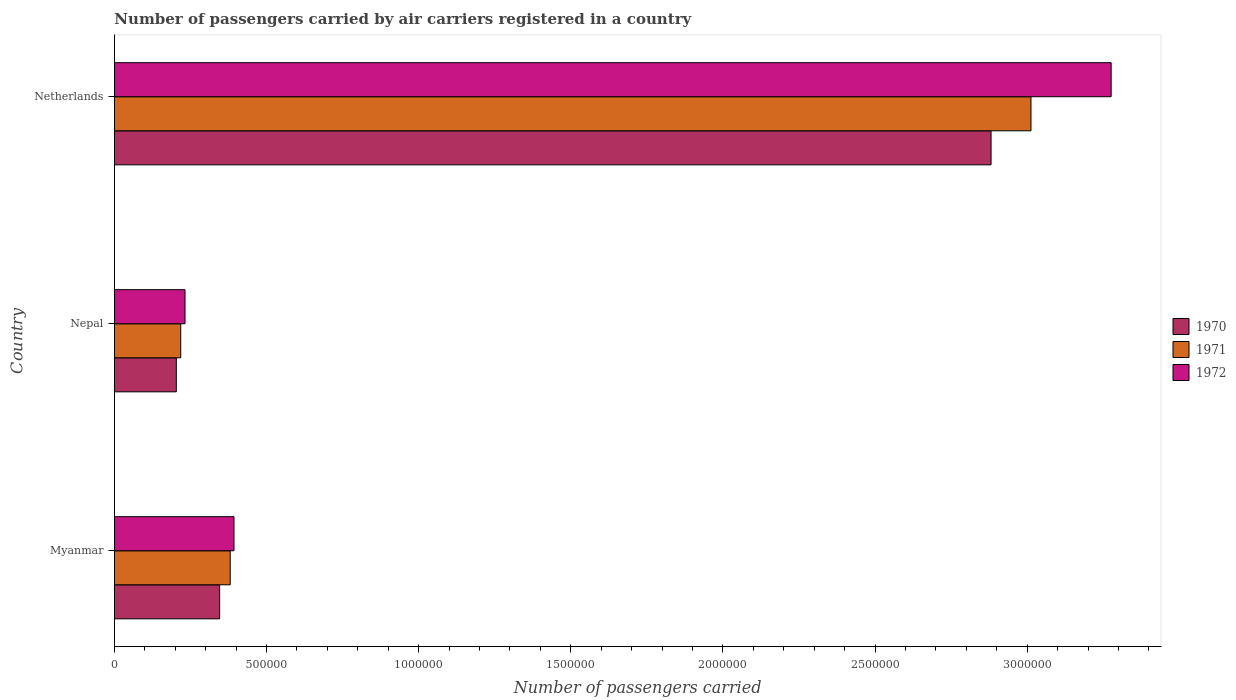How many different coloured bars are there?
Offer a very short reply. 3. How many groups of bars are there?
Your answer should be compact. 3. Are the number of bars per tick equal to the number of legend labels?
Provide a succinct answer. Yes. What is the label of the 2nd group of bars from the top?
Ensure brevity in your answer.  Nepal. In how many cases, is the number of bars for a given country not equal to the number of legend labels?
Offer a very short reply. 0. What is the number of passengers carried by air carriers in 1972 in Nepal?
Your response must be concise. 2.32e+05. Across all countries, what is the maximum number of passengers carried by air carriers in 1972?
Your response must be concise. 3.28e+06. Across all countries, what is the minimum number of passengers carried by air carriers in 1972?
Your answer should be very brief. 2.32e+05. In which country was the number of passengers carried by air carriers in 1972 minimum?
Offer a terse response. Nepal. What is the total number of passengers carried by air carriers in 1970 in the graph?
Make the answer very short. 3.43e+06. What is the difference between the number of passengers carried by air carriers in 1971 in Myanmar and that in Netherlands?
Provide a short and direct response. -2.63e+06. What is the difference between the number of passengers carried by air carriers in 1972 in Netherlands and the number of passengers carried by air carriers in 1970 in Nepal?
Your answer should be compact. 3.07e+06. What is the average number of passengers carried by air carriers in 1972 per country?
Your answer should be very brief. 1.30e+06. What is the difference between the number of passengers carried by air carriers in 1972 and number of passengers carried by air carriers in 1970 in Nepal?
Provide a succinct answer. 2.86e+04. What is the ratio of the number of passengers carried by air carriers in 1970 in Myanmar to that in Nepal?
Ensure brevity in your answer.  1.7. What is the difference between the highest and the second highest number of passengers carried by air carriers in 1972?
Provide a succinct answer. 2.88e+06. What is the difference between the highest and the lowest number of passengers carried by air carriers in 1970?
Provide a short and direct response. 2.68e+06. In how many countries, is the number of passengers carried by air carriers in 1972 greater than the average number of passengers carried by air carriers in 1972 taken over all countries?
Ensure brevity in your answer.  1. What does the 2nd bar from the top in Myanmar represents?
Give a very brief answer. 1971. What does the 3rd bar from the bottom in Myanmar represents?
Offer a terse response. 1972. Is it the case that in every country, the sum of the number of passengers carried by air carriers in 1971 and number of passengers carried by air carriers in 1970 is greater than the number of passengers carried by air carriers in 1972?
Offer a very short reply. Yes. How many countries are there in the graph?
Ensure brevity in your answer.  3. What is the difference between two consecutive major ticks on the X-axis?
Provide a short and direct response. 5.00e+05. Are the values on the major ticks of X-axis written in scientific E-notation?
Give a very brief answer. No. Does the graph contain grids?
Provide a short and direct response. No. How many legend labels are there?
Your answer should be compact. 3. What is the title of the graph?
Offer a very short reply. Number of passengers carried by air carriers registered in a country. What is the label or title of the X-axis?
Provide a short and direct response. Number of passengers carried. What is the label or title of the Y-axis?
Provide a succinct answer. Country. What is the Number of passengers carried of 1970 in Myanmar?
Provide a succinct answer. 3.46e+05. What is the Number of passengers carried of 1971 in Myanmar?
Your response must be concise. 3.80e+05. What is the Number of passengers carried in 1972 in Myanmar?
Offer a terse response. 3.93e+05. What is the Number of passengers carried in 1970 in Nepal?
Ensure brevity in your answer.  2.03e+05. What is the Number of passengers carried in 1971 in Nepal?
Give a very brief answer. 2.18e+05. What is the Number of passengers carried in 1972 in Nepal?
Provide a short and direct response. 2.32e+05. What is the Number of passengers carried of 1970 in Netherlands?
Give a very brief answer. 2.88e+06. What is the Number of passengers carried in 1971 in Netherlands?
Your answer should be compact. 3.01e+06. What is the Number of passengers carried in 1972 in Netherlands?
Offer a terse response. 3.28e+06. Across all countries, what is the maximum Number of passengers carried in 1970?
Your response must be concise. 2.88e+06. Across all countries, what is the maximum Number of passengers carried in 1971?
Give a very brief answer. 3.01e+06. Across all countries, what is the maximum Number of passengers carried of 1972?
Your answer should be very brief. 3.28e+06. Across all countries, what is the minimum Number of passengers carried in 1970?
Make the answer very short. 2.03e+05. Across all countries, what is the minimum Number of passengers carried of 1971?
Offer a terse response. 2.18e+05. Across all countries, what is the minimum Number of passengers carried in 1972?
Make the answer very short. 2.32e+05. What is the total Number of passengers carried of 1970 in the graph?
Provide a succinct answer. 3.43e+06. What is the total Number of passengers carried in 1971 in the graph?
Offer a very short reply. 3.61e+06. What is the total Number of passengers carried in 1972 in the graph?
Make the answer very short. 3.90e+06. What is the difference between the Number of passengers carried of 1970 in Myanmar and that in Nepal?
Provide a short and direct response. 1.42e+05. What is the difference between the Number of passengers carried of 1971 in Myanmar and that in Nepal?
Provide a short and direct response. 1.63e+05. What is the difference between the Number of passengers carried in 1972 in Myanmar and that in Nepal?
Provide a succinct answer. 1.61e+05. What is the difference between the Number of passengers carried of 1970 in Myanmar and that in Netherlands?
Make the answer very short. -2.54e+06. What is the difference between the Number of passengers carried of 1971 in Myanmar and that in Netherlands?
Your answer should be compact. -2.63e+06. What is the difference between the Number of passengers carried in 1972 in Myanmar and that in Netherlands?
Provide a succinct answer. -2.88e+06. What is the difference between the Number of passengers carried of 1970 in Nepal and that in Netherlands?
Make the answer very short. -2.68e+06. What is the difference between the Number of passengers carried in 1971 in Nepal and that in Netherlands?
Give a very brief answer. -2.79e+06. What is the difference between the Number of passengers carried in 1972 in Nepal and that in Netherlands?
Ensure brevity in your answer.  -3.04e+06. What is the difference between the Number of passengers carried in 1970 in Myanmar and the Number of passengers carried in 1971 in Nepal?
Your answer should be very brief. 1.28e+05. What is the difference between the Number of passengers carried in 1970 in Myanmar and the Number of passengers carried in 1972 in Nepal?
Your answer should be compact. 1.14e+05. What is the difference between the Number of passengers carried in 1971 in Myanmar and the Number of passengers carried in 1972 in Nepal?
Your response must be concise. 1.48e+05. What is the difference between the Number of passengers carried in 1970 in Myanmar and the Number of passengers carried in 1971 in Netherlands?
Give a very brief answer. -2.67e+06. What is the difference between the Number of passengers carried in 1970 in Myanmar and the Number of passengers carried in 1972 in Netherlands?
Offer a very short reply. -2.93e+06. What is the difference between the Number of passengers carried in 1971 in Myanmar and the Number of passengers carried in 1972 in Netherlands?
Give a very brief answer. -2.90e+06. What is the difference between the Number of passengers carried in 1970 in Nepal and the Number of passengers carried in 1971 in Netherlands?
Give a very brief answer. -2.81e+06. What is the difference between the Number of passengers carried in 1970 in Nepal and the Number of passengers carried in 1972 in Netherlands?
Your response must be concise. -3.07e+06. What is the difference between the Number of passengers carried of 1971 in Nepal and the Number of passengers carried of 1972 in Netherlands?
Ensure brevity in your answer.  -3.06e+06. What is the average Number of passengers carried in 1970 per country?
Keep it short and to the point. 1.14e+06. What is the average Number of passengers carried in 1971 per country?
Your answer should be compact. 1.20e+06. What is the average Number of passengers carried in 1972 per country?
Offer a terse response. 1.30e+06. What is the difference between the Number of passengers carried in 1970 and Number of passengers carried in 1971 in Myanmar?
Your answer should be very brief. -3.47e+04. What is the difference between the Number of passengers carried of 1970 and Number of passengers carried of 1972 in Myanmar?
Your answer should be compact. -4.72e+04. What is the difference between the Number of passengers carried of 1971 and Number of passengers carried of 1972 in Myanmar?
Provide a succinct answer. -1.25e+04. What is the difference between the Number of passengers carried of 1970 and Number of passengers carried of 1971 in Nepal?
Keep it short and to the point. -1.45e+04. What is the difference between the Number of passengers carried of 1970 and Number of passengers carried of 1972 in Nepal?
Give a very brief answer. -2.86e+04. What is the difference between the Number of passengers carried of 1971 and Number of passengers carried of 1972 in Nepal?
Give a very brief answer. -1.41e+04. What is the difference between the Number of passengers carried in 1970 and Number of passengers carried in 1971 in Netherlands?
Your answer should be very brief. -1.31e+05. What is the difference between the Number of passengers carried in 1970 and Number of passengers carried in 1972 in Netherlands?
Your response must be concise. -3.95e+05. What is the difference between the Number of passengers carried of 1971 and Number of passengers carried of 1972 in Netherlands?
Provide a succinct answer. -2.64e+05. What is the ratio of the Number of passengers carried of 1970 in Myanmar to that in Nepal?
Offer a very short reply. 1.7. What is the ratio of the Number of passengers carried in 1971 in Myanmar to that in Nepal?
Give a very brief answer. 1.75. What is the ratio of the Number of passengers carried of 1972 in Myanmar to that in Nepal?
Your answer should be compact. 1.69. What is the ratio of the Number of passengers carried of 1970 in Myanmar to that in Netherlands?
Make the answer very short. 0.12. What is the ratio of the Number of passengers carried of 1971 in Myanmar to that in Netherlands?
Offer a very short reply. 0.13. What is the ratio of the Number of passengers carried in 1972 in Myanmar to that in Netherlands?
Offer a terse response. 0.12. What is the ratio of the Number of passengers carried in 1970 in Nepal to that in Netherlands?
Offer a terse response. 0.07. What is the ratio of the Number of passengers carried of 1971 in Nepal to that in Netherlands?
Provide a short and direct response. 0.07. What is the ratio of the Number of passengers carried of 1972 in Nepal to that in Netherlands?
Make the answer very short. 0.07. What is the difference between the highest and the second highest Number of passengers carried in 1970?
Your response must be concise. 2.54e+06. What is the difference between the highest and the second highest Number of passengers carried in 1971?
Give a very brief answer. 2.63e+06. What is the difference between the highest and the second highest Number of passengers carried in 1972?
Your answer should be very brief. 2.88e+06. What is the difference between the highest and the lowest Number of passengers carried in 1970?
Ensure brevity in your answer.  2.68e+06. What is the difference between the highest and the lowest Number of passengers carried in 1971?
Provide a succinct answer. 2.79e+06. What is the difference between the highest and the lowest Number of passengers carried of 1972?
Provide a short and direct response. 3.04e+06. 